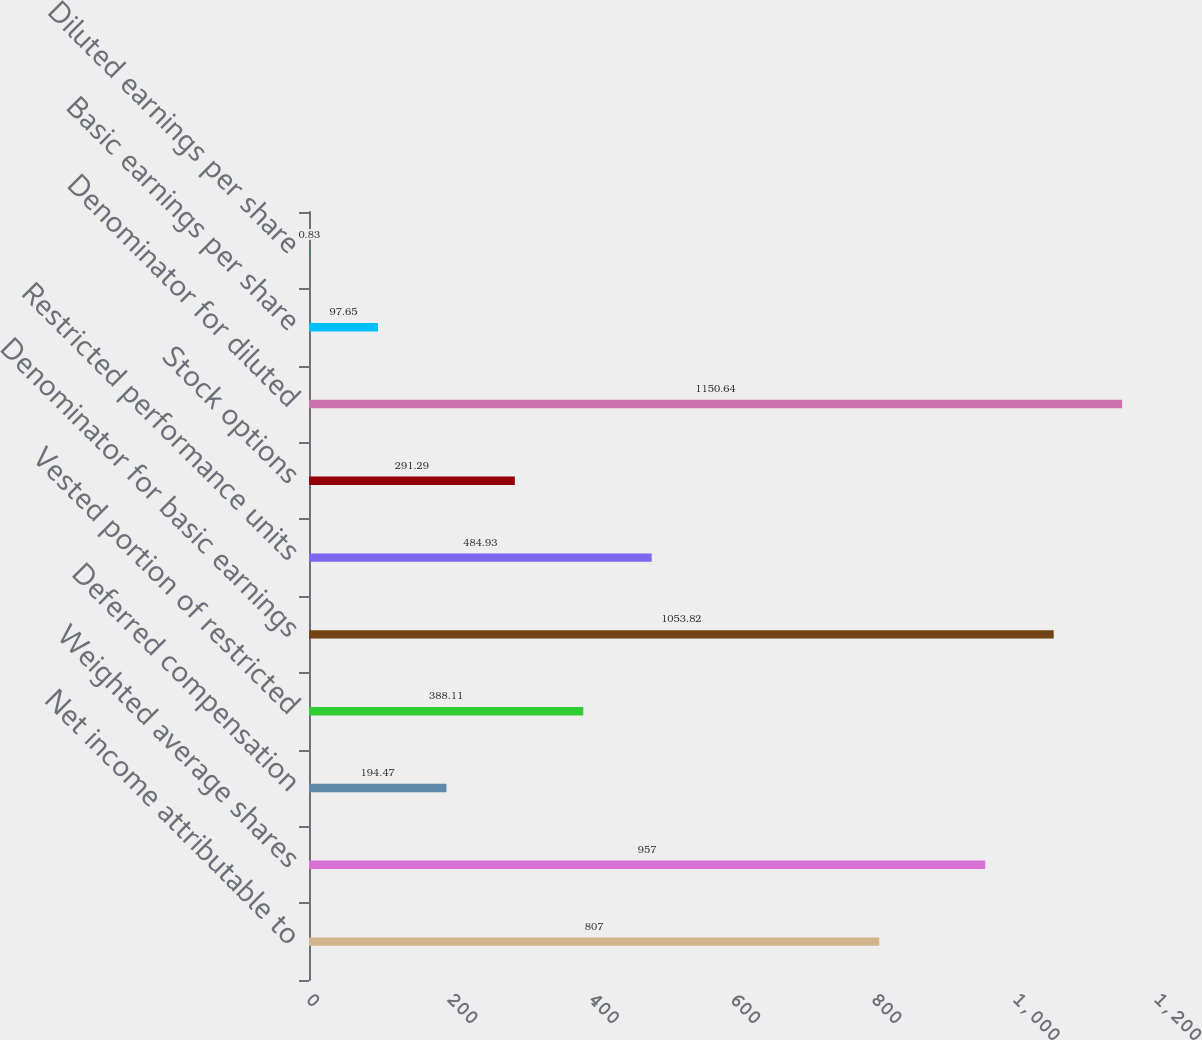<chart> <loc_0><loc_0><loc_500><loc_500><bar_chart><fcel>Net income attributable to<fcel>Weighted average shares<fcel>Deferred compensation<fcel>Vested portion of restricted<fcel>Denominator for basic earnings<fcel>Restricted performance units<fcel>Stock options<fcel>Denominator for diluted<fcel>Basic earnings per share<fcel>Diluted earnings per share<nl><fcel>807<fcel>957<fcel>194.47<fcel>388.11<fcel>1053.82<fcel>484.93<fcel>291.29<fcel>1150.64<fcel>97.65<fcel>0.83<nl></chart> 